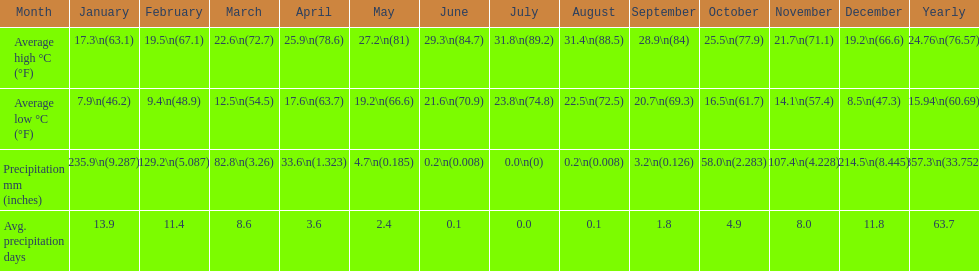Which month held the most precipitation? January. 